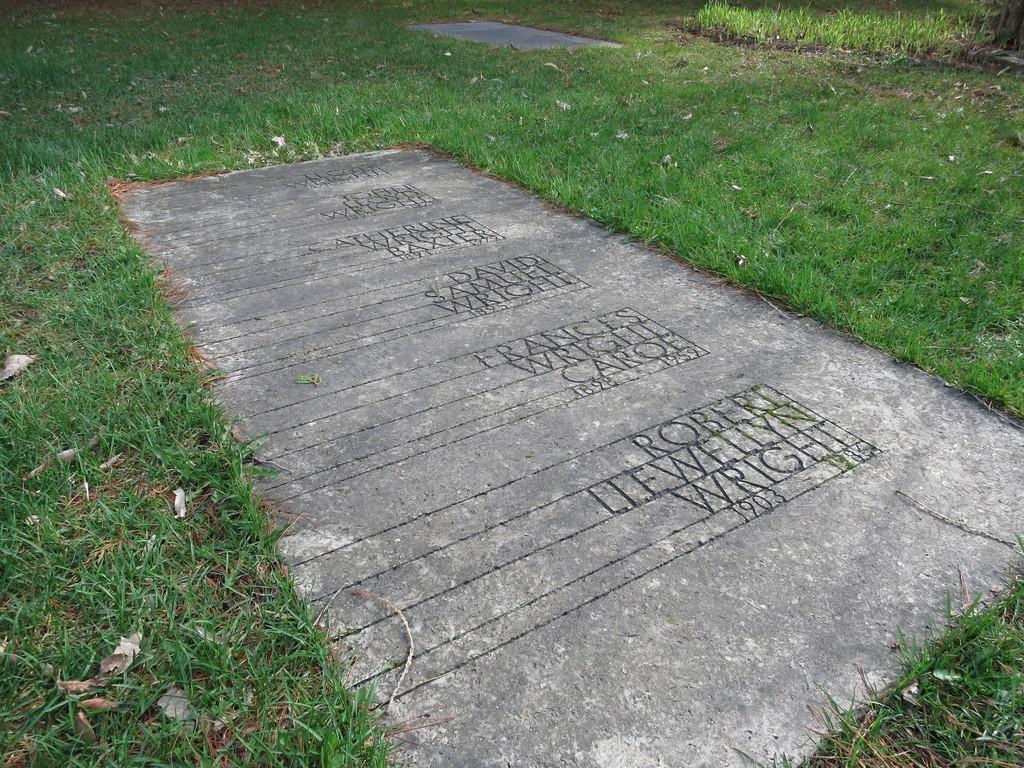Describe this image in one or two sentences. In this image I can see a stone with some text written on it. In the background, I can see the grass. 